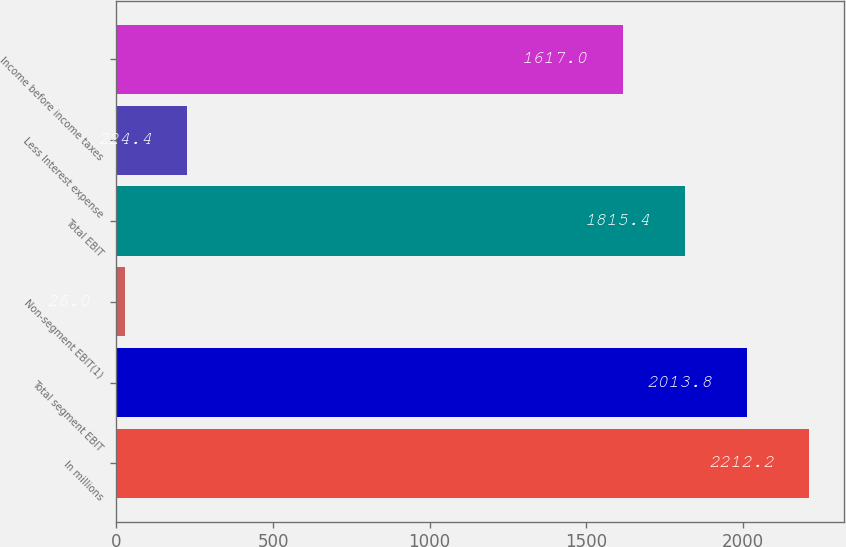Convert chart. <chart><loc_0><loc_0><loc_500><loc_500><bar_chart><fcel>In millions<fcel>Total segment EBIT<fcel>Non-segment EBIT(1)<fcel>Total EBIT<fcel>Less Interest expense<fcel>Income before income taxes<nl><fcel>2212.2<fcel>2013.8<fcel>26<fcel>1815.4<fcel>224.4<fcel>1617<nl></chart> 